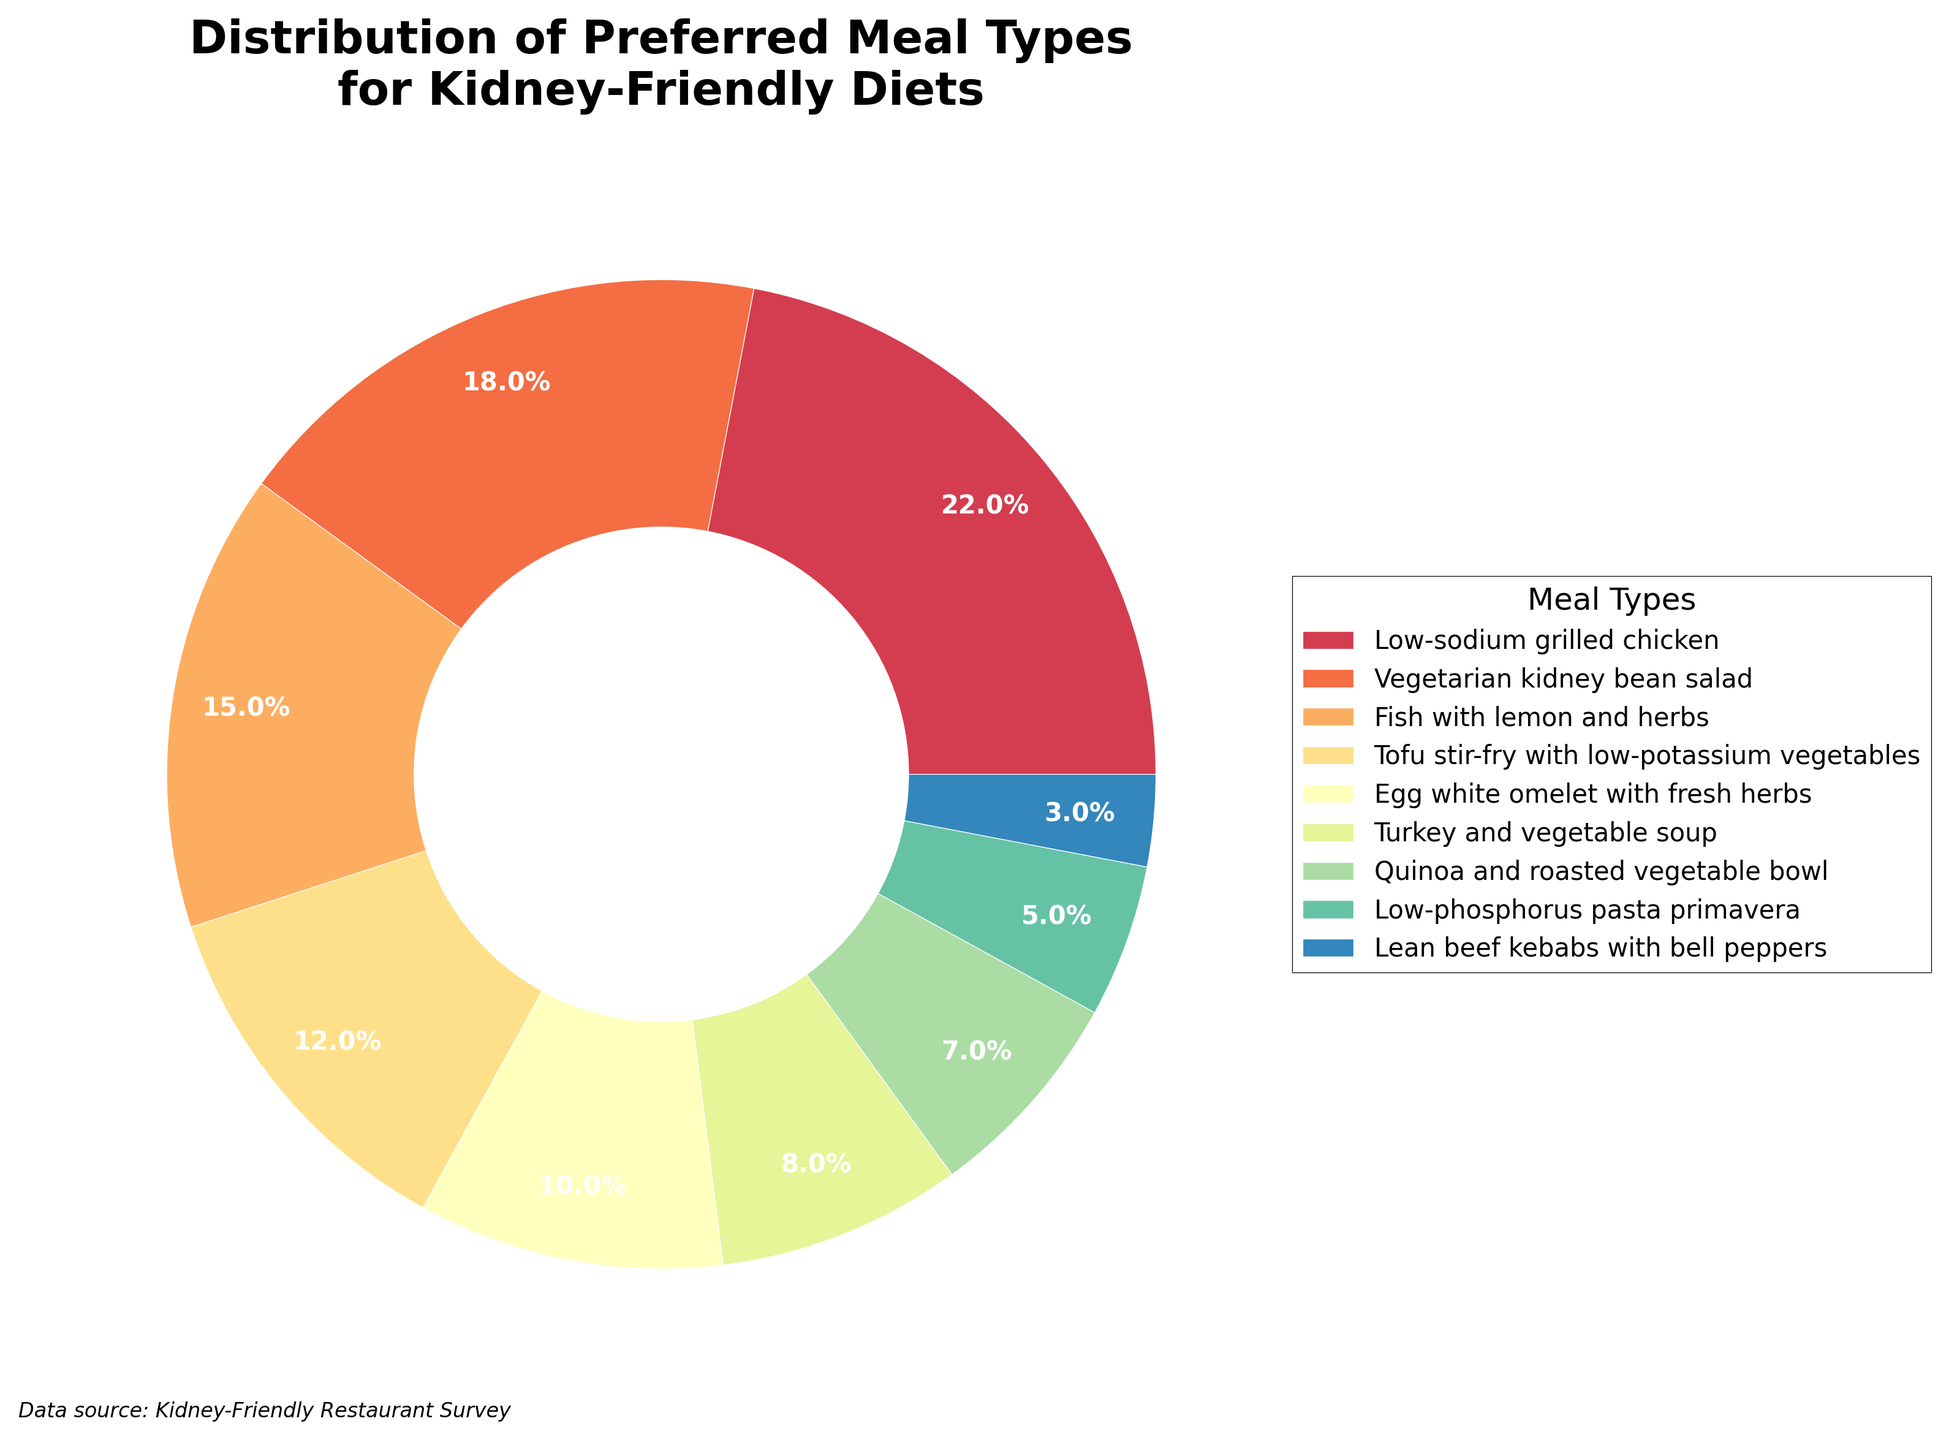Which meal type has the highest percentage? The meal type with the highest percentage is "Low-sodium grilled chicken" with 22%.
Answer: Low-sodium grilled chicken How much higher is the percentage of Low-sodium grilled chicken compared to Lean beef kebabs with bell peppers? To find the difference, subtract the percentage of Lean beef kebabs with bell peppers (3%) from the percentage of Low-sodium grilled chicken (22%): 22% - 3% = 19%.
Answer: 19% What is the combined percentage of Turkey and vegetable soup, Quinoa and roasted vegetable bowl, and Low-phosphorus pasta primavera? Add the percentages of Turkey and vegetable soup (8%), Quinoa and roasted vegetable bowl (7%), and Low-phosphorus pasta primavera (5%): 8% + 7% + 5% = 20%.
Answer: 20% Which has a higher percentage: Fish with lemon and herbs or Tofu stir-fry with low-potassium vegetables? Fish with lemon and herbs has 15%, and Tofu stir-fry with low-potassium vegetables has 12%. 15% is higher than 12%.
Answer: Fish with lemon and herbs What is the smallest percentage among all meal types? The smallest percentage among all meal types is 3%, which corresponds to Lean beef kebabs with bell peppers.
Answer: 3% Is the percentage of Egg white omelet with fresh herbs higher or lower than the average percentage of all items? First, calculate the average percentage. Sum all percentages and divide by the number of items: (22 + 18 + 15 + 12 + 10 + 8 + 7 + 5 + 3) / 9 = 100 / 9 ≈ 11.11%. The percentage for Egg white omelet with fresh herbs is 10%, which is lower than 11.11%.
Answer: Lower Which meal type represents exactly 10%? The meal type that represents exactly 10% is Egg white omelet with fresh herbs.
Answer: Egg white omelet with fresh herbs What percentage do the three least preferred meal types make up? The three least preferred meal types are Lean beef kebabs with bell peppers (3%), Low-phosphorus pasta primavera (5%), and Quinoa and roasted vegetable bowl (7%). Their combined percentage is 3% + 5% + 7% = 15%.
Answer: 15% Is the percentage of Vegetarian kidney bean salad closer to the percentage of Low-sodium grilled chicken or Fish with lemon and herbs? Vegetarian kidney bean salad is 18%. The difference from Low-sodium grilled chicken (22%) is 22% - 18% = 4%, and from Fish with lemon and herbs (15%) is 18% - 15% = 3%. 3% is smaller than 4%, so it is closer to Fish with lemon and herbs.
Answer: Fish with lemon and herbs What visual attribute is used to differentiate the meal types in the pie chart? The pie chart uses different colors to distinguish between the meal types.
Answer: Colors 